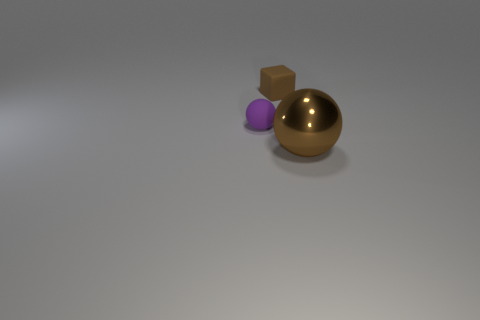What is the shape of the small matte object that is the same color as the metal object?
Offer a terse response. Cube. There is a object that is in front of the small brown object and right of the small ball; what is its material?
Ensure brevity in your answer.  Metal. What is the shape of the rubber object that is behind the small purple rubber sphere?
Ensure brevity in your answer.  Cube. The brown object behind the tiny thing that is in front of the tiny brown object is what shape?
Your answer should be very brief. Cube. Are there any other large brown shiny things that have the same shape as the large metallic object?
Offer a terse response. No. What shape is the object that is the same size as the rubber sphere?
Provide a succinct answer. Cube. Are there any things in front of the brown object behind the sphere to the right of the small purple rubber object?
Provide a short and direct response. Yes. Are there any brown rubber objects that have the same size as the brown cube?
Make the answer very short. No. How big is the brown rubber cube behind the purple sphere?
Keep it short and to the point. Small. The small matte thing that is in front of the brown object to the left of the brown object that is in front of the tiny rubber block is what color?
Make the answer very short. Purple. 